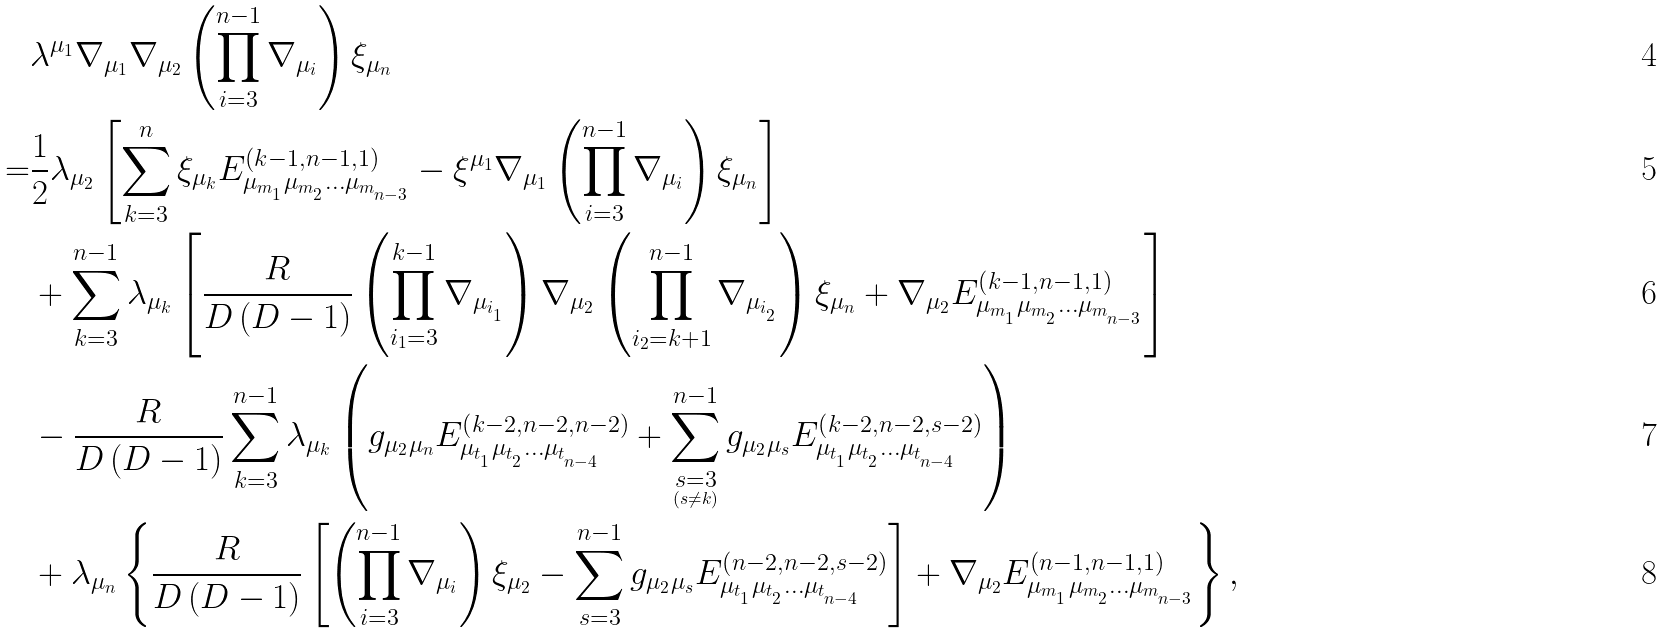Convert formula to latex. <formula><loc_0><loc_0><loc_500><loc_500>& \lambda ^ { \mu _ { 1 } } \nabla _ { \mu _ { 1 } } \nabla _ { \mu _ { 2 } } \left ( \prod _ { i = 3 } ^ { n - 1 } \nabla _ { \mu _ { i } } \right ) \xi _ { \mu _ { n } } \\ = & \frac { 1 } { 2 } \lambda _ { \mu _ { 2 } } \left [ \sum _ { k = 3 } ^ { n } \xi _ { \mu _ { k } } E _ { \mu _ { m _ { _ { 1 } } } \mu _ { m _ { _ { 2 } } } \dots \mu _ { m _ { _ { n - 3 } } } } ^ { \left ( k - 1 , n - 1 , 1 \right ) } - \xi ^ { \mu _ { 1 } } \nabla _ { \mu _ { 1 } } \left ( \prod _ { i = 3 } ^ { n - 1 } \nabla _ { \mu _ { i } } \right ) \xi _ { \mu _ { n } } \right ] \\ & + \sum _ { k = 3 } ^ { n - 1 } \lambda _ { \mu _ { k } } \left [ \frac { R } { D \left ( D - 1 \right ) } \left ( \prod _ { i _ { 1 } = 3 } ^ { k - 1 } \nabla _ { \mu _ { i _ { _ { 1 } } } } \right ) \nabla _ { \mu _ { 2 } } \left ( \prod _ { i _ { 2 } = k + 1 } ^ { n - 1 } \nabla _ { \mu _ { i _ { _ { 2 } } } } \right ) \xi _ { \mu _ { n } } + \nabla _ { \mu _ { 2 } } E _ { \mu _ { m _ { _ { 1 } } } \mu _ { m _ { _ { 2 } } } \dots \mu _ { m _ { _ { n - 3 } } } } ^ { \left ( k - 1 , n - 1 , 1 \right ) } \right ] \\ & - \frac { R } { D \left ( D - 1 \right ) } \sum _ { k = 3 } ^ { n - 1 } \lambda _ { \mu _ { k } } \left ( g _ { \mu _ { 2 } \mu _ { n } } E _ { \mu _ { t _ { _ { 1 } } } \mu _ { t _ { _ { 2 } } } \dots \mu _ { t _ { _ { n - 4 } } } } ^ { \left ( k - 2 , n - 2 , n - 2 \right ) } + \sum _ { \underset { \left ( s \ne k \right ) } { s = 3 } } ^ { n - 1 } g _ { \mu _ { 2 } \mu _ { s } } E _ { \mu _ { t _ { _ { 1 } } } \mu _ { t _ { _ { 2 } } } \dots \mu _ { t _ { _ { n - 4 } } } } ^ { \left ( k - 2 , n - 2 , s - 2 \right ) } \right ) \\ & + \lambda _ { \mu _ { n } } \left \{ \frac { R } { D \left ( D - 1 \right ) } \left [ \left ( \prod _ { i = 3 } ^ { n - 1 } \nabla _ { \mu _ { i } } \right ) \xi _ { \mu _ { 2 } } - \sum _ { s = 3 } ^ { n - 1 } g _ { \mu _ { 2 } \mu _ { s } } E _ { \mu _ { t _ { _ { 1 } } } \mu _ { t _ { _ { 2 } } } \dots \mu _ { t _ { _ { n - 4 } } } } ^ { \left ( n - 2 , n - 2 , s - 2 \right ) } \right ] + \nabla _ { \mu _ { 2 } } E _ { \mu _ { m _ { _ { 1 } } } \mu _ { m _ { _ { 2 } } } \dots \mu _ { m _ { _ { n - 3 } } } } ^ { \left ( n - 1 , n - 1 , 1 \right ) } \right \} ,</formula> 